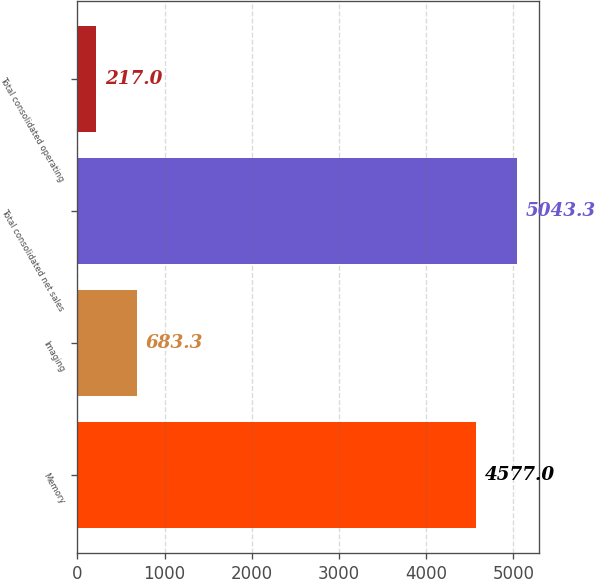Convert chart. <chart><loc_0><loc_0><loc_500><loc_500><bar_chart><fcel>Memory<fcel>Imaging<fcel>Total consolidated net sales<fcel>Total consolidated operating<nl><fcel>4577<fcel>683.3<fcel>5043.3<fcel>217<nl></chart> 